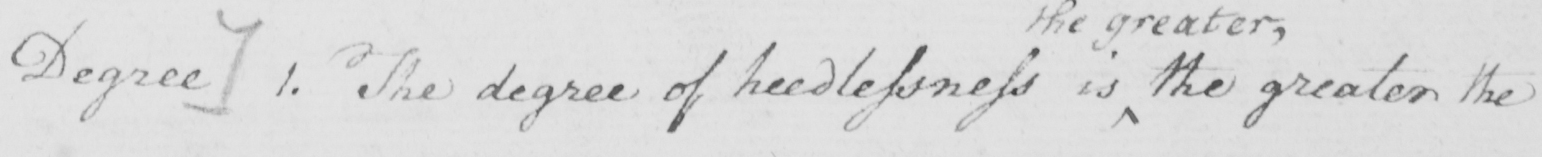What does this handwritten line say? [  ( B )  Degree ]  1 . The degree of heedlessness is the greater the 